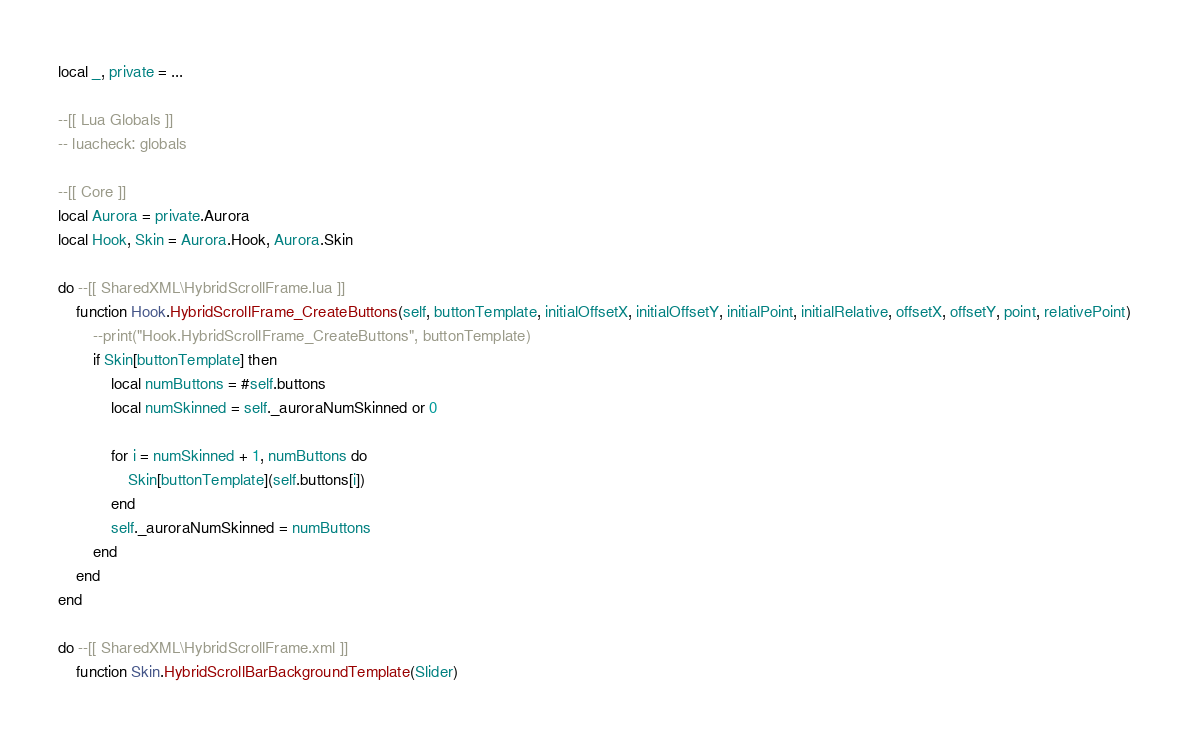Convert code to text. <code><loc_0><loc_0><loc_500><loc_500><_Lua_>local _, private = ...

--[[ Lua Globals ]]
-- luacheck: globals

--[[ Core ]]
local Aurora = private.Aurora
local Hook, Skin = Aurora.Hook, Aurora.Skin

do --[[ SharedXML\HybridScrollFrame.lua ]]
    function Hook.HybridScrollFrame_CreateButtons(self, buttonTemplate, initialOffsetX, initialOffsetY, initialPoint, initialRelative, offsetX, offsetY, point, relativePoint)
        --print("Hook.HybridScrollFrame_CreateButtons", buttonTemplate)
        if Skin[buttonTemplate] then
            local numButtons = #self.buttons
            local numSkinned = self._auroraNumSkinned or 0

            for i = numSkinned + 1, numButtons do
                Skin[buttonTemplate](self.buttons[i])
            end
            self._auroraNumSkinned = numButtons
        end
    end
end

do --[[ SharedXML\HybridScrollFrame.xml ]]
    function Skin.HybridScrollBarBackgroundTemplate(Slider)</code> 